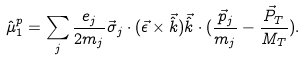<formula> <loc_0><loc_0><loc_500><loc_500>\hat { \mu } ^ { p } _ { 1 } = \sum _ { j } \frac { e _ { j } } { 2 m _ { j } } \vec { \sigma } _ { j } \cdot ( \vec { \epsilon } \times \vec { \hat { k } } ) \vec { \hat { k } } \cdot ( \frac { \vec { p } _ { j } } { m _ { j } } - \frac { \vec { P } _ { T } } { M _ { T } } ) .</formula> 